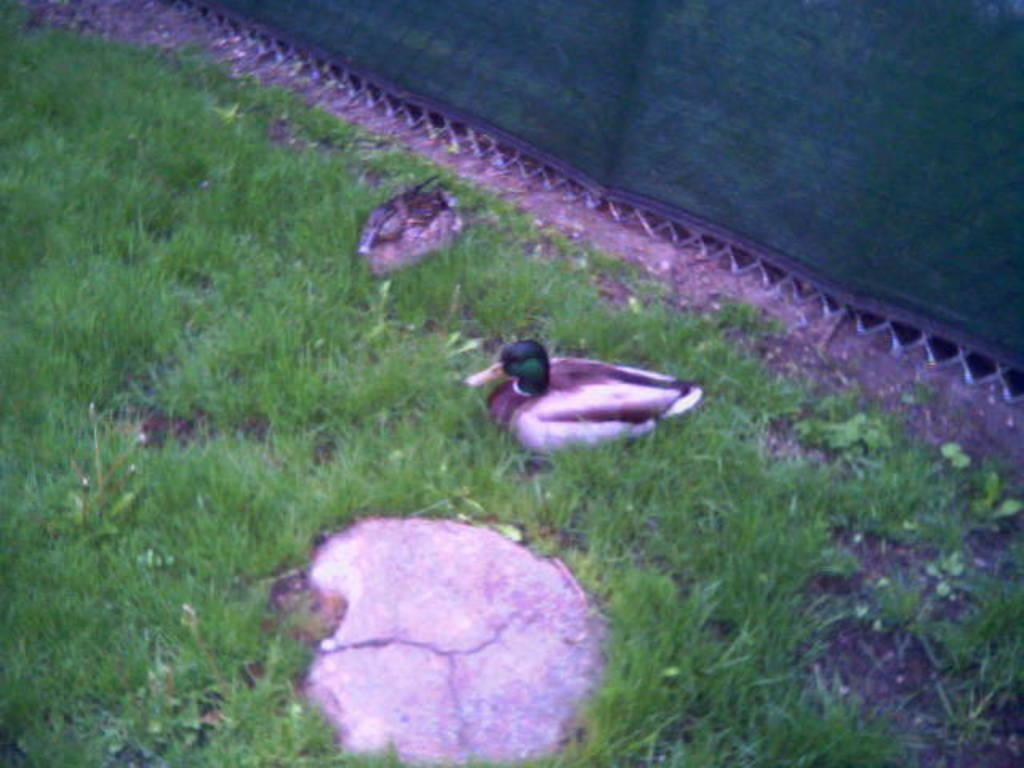Where was the image taken? The image was clicked outside. What can be seen flying in the image? There are birds in the image. What type of vegetation is present in the image? There is green grass in the image. What else can be seen in the image besides the birds and grass? There are other objects in the image. How many babies are crawling on the knee in the image? There are no babies or knees present in the image. 